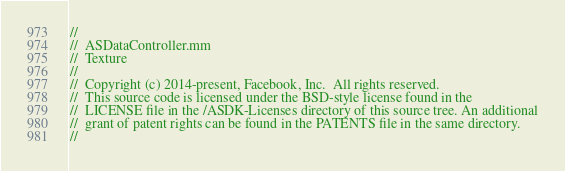<code> <loc_0><loc_0><loc_500><loc_500><_ObjectiveC_>//
//  ASDataController.mm
//  Texture
//
//  Copyright (c) 2014-present, Facebook, Inc.  All rights reserved.
//  This source code is licensed under the BSD-style license found in the
//  LICENSE file in the /ASDK-Licenses directory of this source tree. An additional
//  grant of patent rights can be found in the PATENTS file in the same directory.
//</code> 